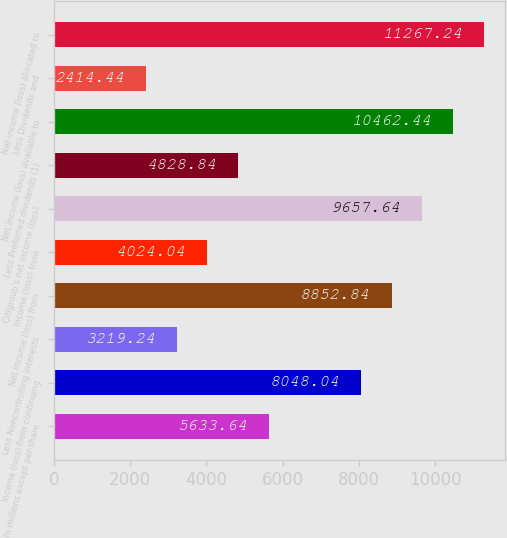<chart> <loc_0><loc_0><loc_500><loc_500><bar_chart><fcel>In millions except per-share<fcel>Income (loss) from continuing<fcel>Less Noncontrolling interests<fcel>Net income (loss) from<fcel>Income (loss) from<fcel>Citigroup's net income (loss)<fcel>Less Preferred dividends (1)<fcel>Net income (loss) available to<fcel>Less Dividends and<fcel>Net income (loss) allocated to<nl><fcel>5633.64<fcel>8048.04<fcel>3219.24<fcel>8852.84<fcel>4024.04<fcel>9657.64<fcel>4828.84<fcel>10462.4<fcel>2414.44<fcel>11267.2<nl></chart> 